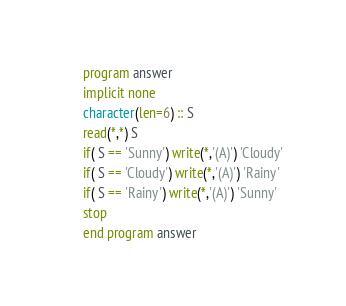Convert code to text. <code><loc_0><loc_0><loc_500><loc_500><_FORTRAN_>      program answer
      implicit none
      character(len=6) :: S
      read(*,*) S
      if( S == 'Sunny') write(*,'(A)') 'Cloudy'
      if( S == 'Cloudy') write(*,'(A)') 'Rainy'
      if( S == 'Rainy') write(*,'(A)') 'Sunny'
      stop
      end program answer</code> 